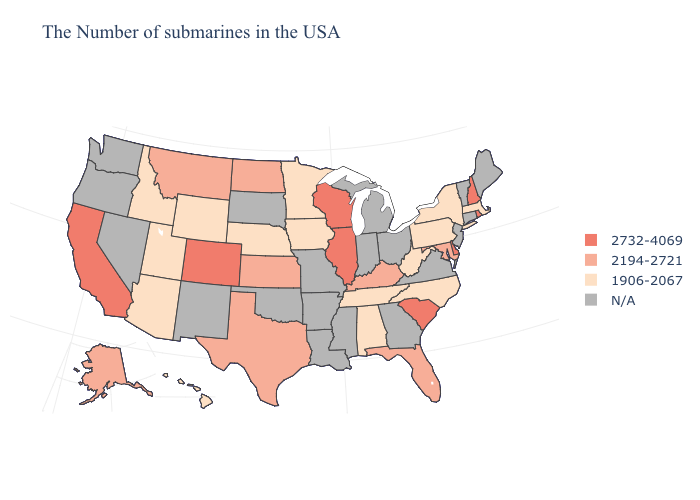What is the lowest value in states that border Iowa?
Write a very short answer. 1906-2067. What is the value of Wisconsin?
Quick response, please. 2732-4069. What is the lowest value in the South?
Quick response, please. 1906-2067. Name the states that have a value in the range 1906-2067?
Concise answer only. Massachusetts, New York, Pennsylvania, North Carolina, West Virginia, Alabama, Tennessee, Minnesota, Iowa, Nebraska, Wyoming, Utah, Arizona, Idaho, Hawaii. What is the lowest value in states that border Arizona?
Concise answer only. 1906-2067. What is the value of Hawaii?
Short answer required. 1906-2067. Among the states that border New York , which have the highest value?
Quick response, please. Massachusetts, Pennsylvania. Name the states that have a value in the range N/A?
Keep it brief. Maine, Vermont, Connecticut, New Jersey, Virginia, Ohio, Georgia, Michigan, Indiana, Mississippi, Louisiana, Missouri, Arkansas, Oklahoma, South Dakota, New Mexico, Nevada, Washington, Oregon. What is the highest value in states that border Oklahoma?
Give a very brief answer. 2732-4069. What is the value of Pennsylvania?
Be succinct. 1906-2067. Among the states that border North Dakota , does Montana have the lowest value?
Give a very brief answer. No. Name the states that have a value in the range N/A?
Quick response, please. Maine, Vermont, Connecticut, New Jersey, Virginia, Ohio, Georgia, Michigan, Indiana, Mississippi, Louisiana, Missouri, Arkansas, Oklahoma, South Dakota, New Mexico, Nevada, Washington, Oregon. Does North Dakota have the highest value in the MidWest?
Keep it brief. No. What is the value of California?
Short answer required. 2732-4069. 